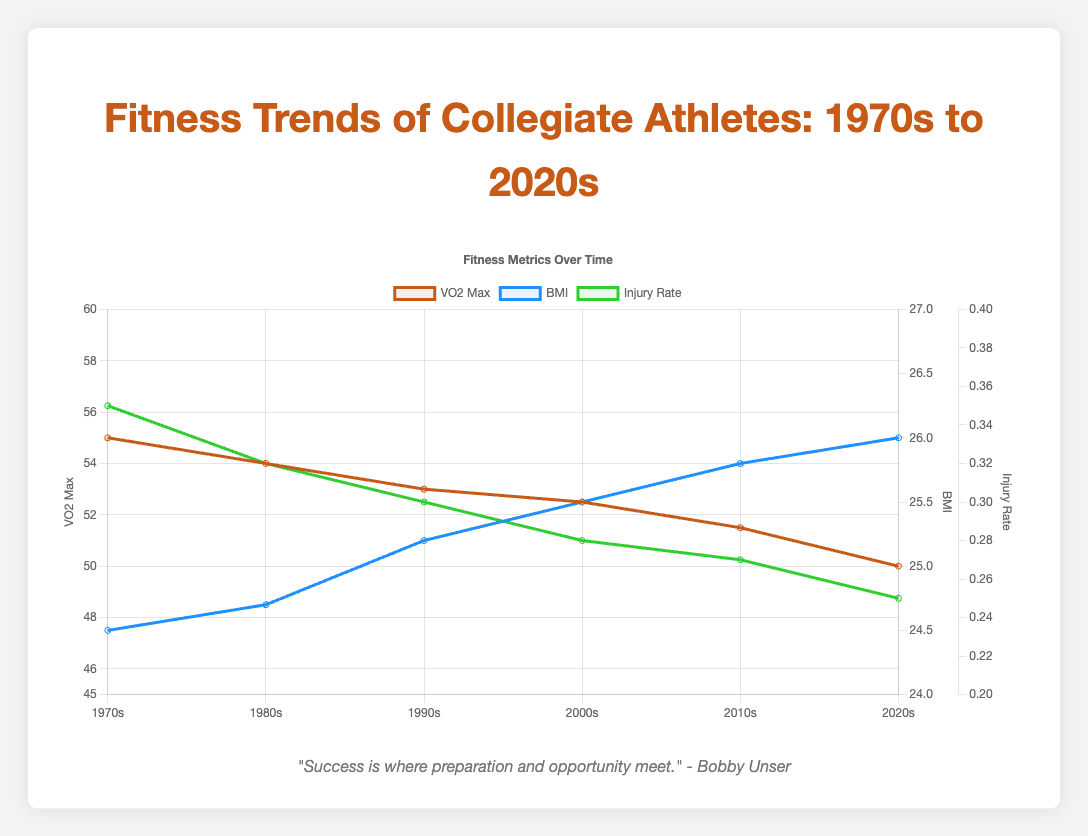Which era has the highest VO2 max value? The highest VO2 Max value is indicated by the peak of the red line on the graph for different eras. The highest point occurs in the 1970s.
Answer: 1970s What is the difference in VO2 max between the 1970s and 2020s? Locate the VO2 Max values for the 1970s (55.0) and 2020s (50.0) from the red line. Subtract the 2020s value from the 1970s value: 55.0 - 50.0 = 5.0
Answer: 5.0 How does BMI in the 1990s compare to BMI in the 2010s? BMI values for the 1990s (25.2) and the 2010s (25.8) are found by following the blue line on the graph. Comparing these values shows that BMI was lower in the 1990s.
Answer: Lower By how much has the injury rate decreased from the 1980s to the 2020s? Identify injury rates in the 1980s (0.32) and 2020s (0.25) from the green line on the graph. The decrease can be found by subtracting the 2020s value from the 1980s value: 0.32 - 0.25 = 0.07
Answer: 0.07 What is the average BMI across all eras? Add up the BMI values for all eras: 24.5 + 24.7 + 25.2 + 25.5 + 25.8 + 26.0 = 151.7. Divide by the number of eras (6): 151.7 / 6 = 25.28
Answer: 25.28 Which era shows the lowest injury rate? The lowest point on the green line indicates the era with the lowest injury rate, which is the 2020s with an injury rate of 0.25.
Answer: 2020s Compare the VO2 max trend with the BMI trend over the eras. The VO2 Max value (red line) consistently decreases over time from 55.0 in the 1970s to 50.0 in the 2020s. Conversely, the BMI value (blue line) consistently increases over time from 24.5 in the 1970s to 26.0 in the 2020s.
Answer: VO2 Max decreases, BMI increases What is the total change in injury rate from the 1970s to the 2020s? Subtract the injury rate in the 2020s (0.25) from the injury rate in the 1970s (0.35): 0.35 - 0.25 = 0.10
Answer: 0.10 